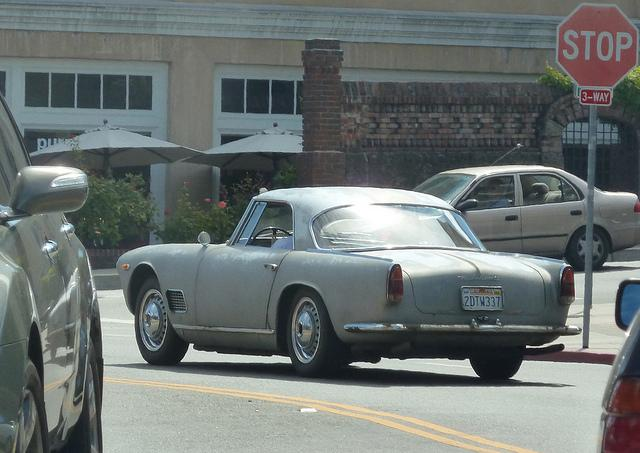How many turn options do cars entering this intersection have? two 